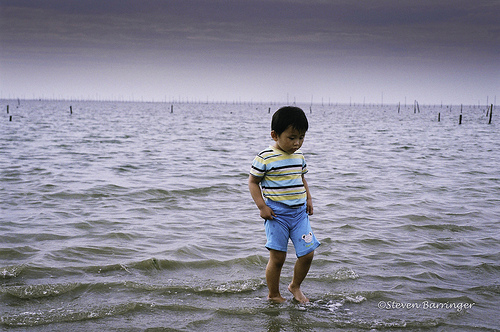<image>
Is there a child next to the water? No. The child is not positioned next to the water. They are located in different areas of the scene. 